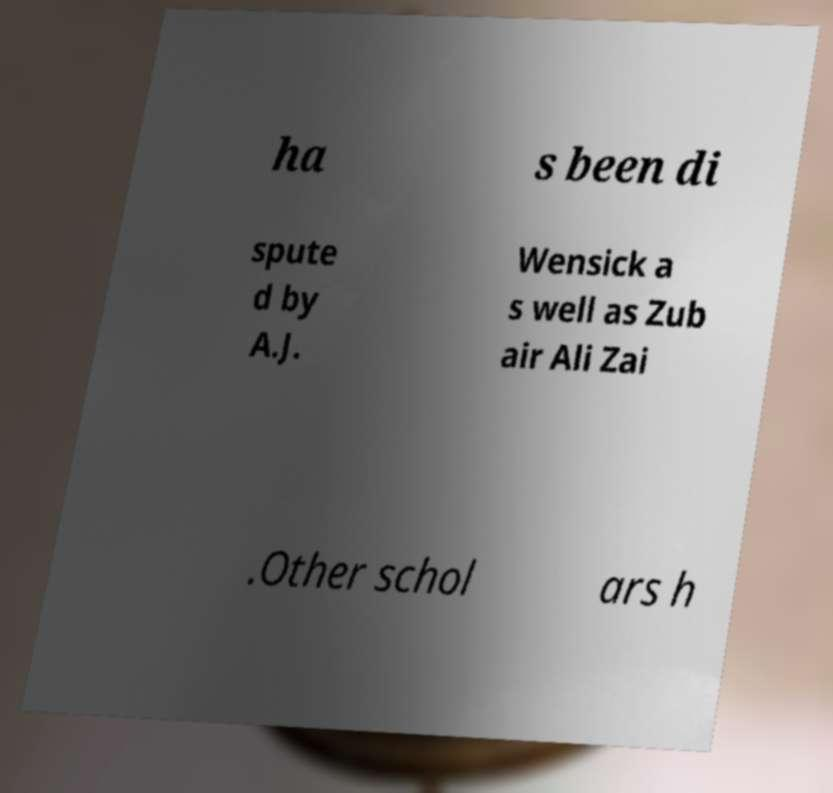Please identify and transcribe the text found in this image. ha s been di spute d by A.J. Wensick a s well as Zub air Ali Zai .Other schol ars h 